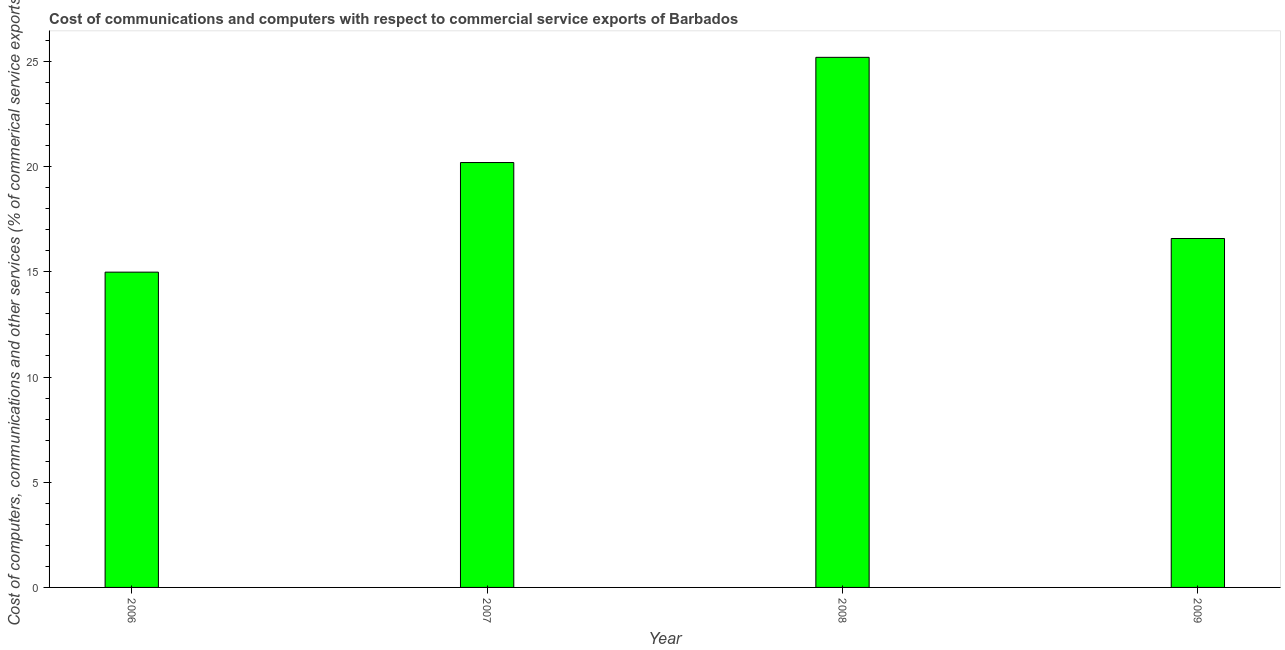Does the graph contain any zero values?
Your answer should be very brief. No. What is the title of the graph?
Your response must be concise. Cost of communications and computers with respect to commercial service exports of Barbados. What is the label or title of the X-axis?
Provide a succinct answer. Year. What is the label or title of the Y-axis?
Offer a very short reply. Cost of computers, communications and other services (% of commerical service exports). What is the  computer and other services in 2007?
Your answer should be compact. 20.2. Across all years, what is the maximum cost of communications?
Your answer should be compact. 25.2. Across all years, what is the minimum cost of communications?
Offer a very short reply. 14.99. In which year was the  computer and other services maximum?
Provide a succinct answer. 2008. What is the sum of the cost of communications?
Ensure brevity in your answer.  76.96. What is the difference between the cost of communications in 2007 and 2008?
Offer a terse response. -5. What is the average cost of communications per year?
Make the answer very short. 19.24. What is the median  computer and other services?
Ensure brevity in your answer.  18.39. What is the ratio of the  computer and other services in 2006 to that in 2008?
Ensure brevity in your answer.  0.59. Is the  computer and other services in 2008 less than that in 2009?
Your answer should be compact. No. What is the difference between the highest and the second highest  computer and other services?
Make the answer very short. 5. Is the sum of the  computer and other services in 2007 and 2008 greater than the maximum  computer and other services across all years?
Offer a terse response. Yes. What is the difference between the highest and the lowest  computer and other services?
Offer a very short reply. 10.21. Are the values on the major ticks of Y-axis written in scientific E-notation?
Ensure brevity in your answer.  No. What is the Cost of computers, communications and other services (% of commerical service exports) in 2006?
Ensure brevity in your answer.  14.99. What is the Cost of computers, communications and other services (% of commerical service exports) in 2007?
Give a very brief answer. 20.2. What is the Cost of computers, communications and other services (% of commerical service exports) of 2008?
Your answer should be very brief. 25.2. What is the Cost of computers, communications and other services (% of commerical service exports) of 2009?
Provide a succinct answer. 16.58. What is the difference between the Cost of computers, communications and other services (% of commerical service exports) in 2006 and 2007?
Provide a short and direct response. -5.21. What is the difference between the Cost of computers, communications and other services (% of commerical service exports) in 2006 and 2008?
Ensure brevity in your answer.  -10.21. What is the difference between the Cost of computers, communications and other services (% of commerical service exports) in 2006 and 2009?
Make the answer very short. -1.6. What is the difference between the Cost of computers, communications and other services (% of commerical service exports) in 2007 and 2008?
Provide a short and direct response. -5. What is the difference between the Cost of computers, communications and other services (% of commerical service exports) in 2007 and 2009?
Keep it short and to the point. 3.61. What is the difference between the Cost of computers, communications and other services (% of commerical service exports) in 2008 and 2009?
Keep it short and to the point. 8.61. What is the ratio of the Cost of computers, communications and other services (% of commerical service exports) in 2006 to that in 2007?
Provide a succinct answer. 0.74. What is the ratio of the Cost of computers, communications and other services (% of commerical service exports) in 2006 to that in 2008?
Make the answer very short. 0.59. What is the ratio of the Cost of computers, communications and other services (% of commerical service exports) in 2006 to that in 2009?
Offer a very short reply. 0.9. What is the ratio of the Cost of computers, communications and other services (% of commerical service exports) in 2007 to that in 2008?
Give a very brief answer. 0.8. What is the ratio of the Cost of computers, communications and other services (% of commerical service exports) in 2007 to that in 2009?
Give a very brief answer. 1.22. What is the ratio of the Cost of computers, communications and other services (% of commerical service exports) in 2008 to that in 2009?
Your answer should be compact. 1.52. 